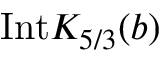Convert formula to latex. <formula><loc_0><loc_0><loc_500><loc_500>I n t K _ { 5 / 3 } ( b )</formula> 